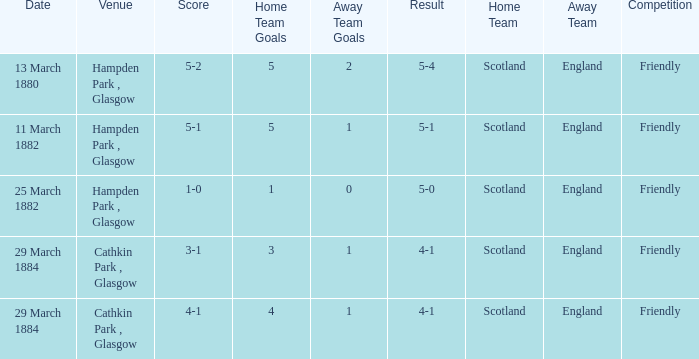Which item has a score of 5-1? 5-1. Would you be able to parse every entry in this table? {'header': ['Date', 'Venue', 'Score', 'Home Team Goals', 'Away Team Goals', 'Result', 'Home Team', 'Away Team', 'Competition'], 'rows': [['13 March 1880', 'Hampden Park , Glasgow', '5-2', '5', '2', '5-4', 'Scotland', 'England', 'Friendly'], ['11 March 1882', 'Hampden Park , Glasgow', '5-1', '5', '1', '5-1', 'Scotland', 'England', 'Friendly'], ['25 March 1882', 'Hampden Park , Glasgow', '1-0', '1', '0', '5-0', 'Scotland', 'England', 'Friendly'], ['29 March 1884', 'Cathkin Park , Glasgow', '3-1', '3', '1', '4-1', 'Scotland', 'England', 'Friendly'], ['29 March 1884', 'Cathkin Park , Glasgow', '4-1', '4', '1', '4-1', 'Scotland', 'England', 'Friendly']]} 